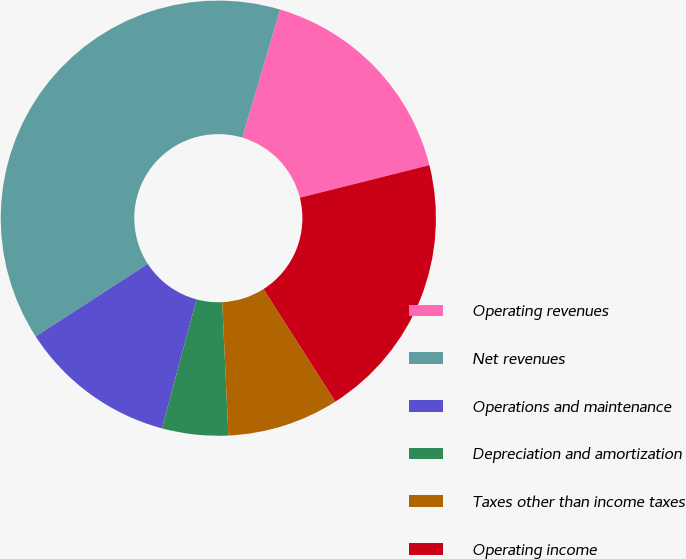<chart> <loc_0><loc_0><loc_500><loc_500><pie_chart><fcel>Operating revenues<fcel>Net revenues<fcel>Operations and maintenance<fcel>Depreciation and amortization<fcel>Taxes other than income taxes<fcel>Operating income<nl><fcel>16.5%<fcel>38.73%<fcel>11.68%<fcel>4.91%<fcel>8.3%<fcel>19.88%<nl></chart> 